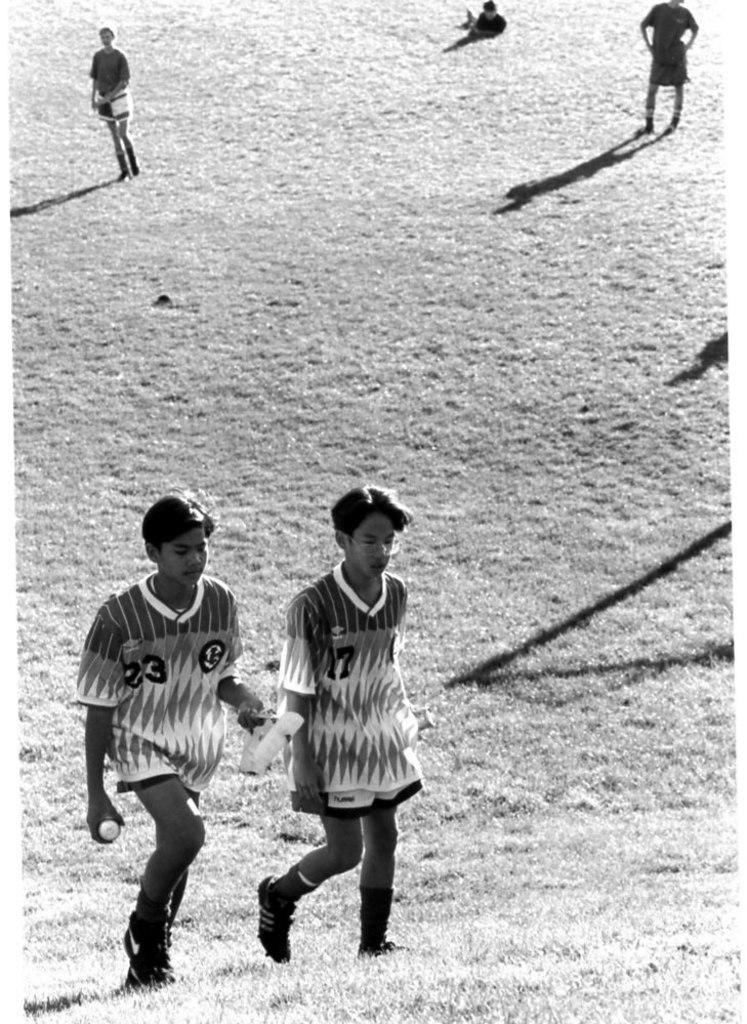What is the color scheme of the image? The image is in black and white. What can be seen in the image besides the color scheme? There are people and grassland visible in the image. What type of brush is being used by the authority figure in the image? There is no brush or authority figure present in the image. How is the control exercised in the image? The image does not depict any control or authority figures, so it is not possible to determine how control is exercised. 